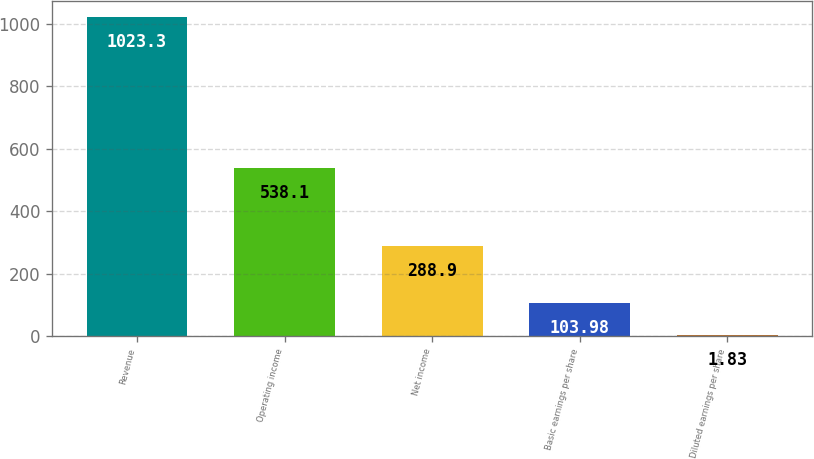Convert chart. <chart><loc_0><loc_0><loc_500><loc_500><bar_chart><fcel>Revenue<fcel>Operating income<fcel>Net income<fcel>Basic earnings per share<fcel>Diluted earnings per share<nl><fcel>1023.3<fcel>538.1<fcel>288.9<fcel>103.98<fcel>1.83<nl></chart> 